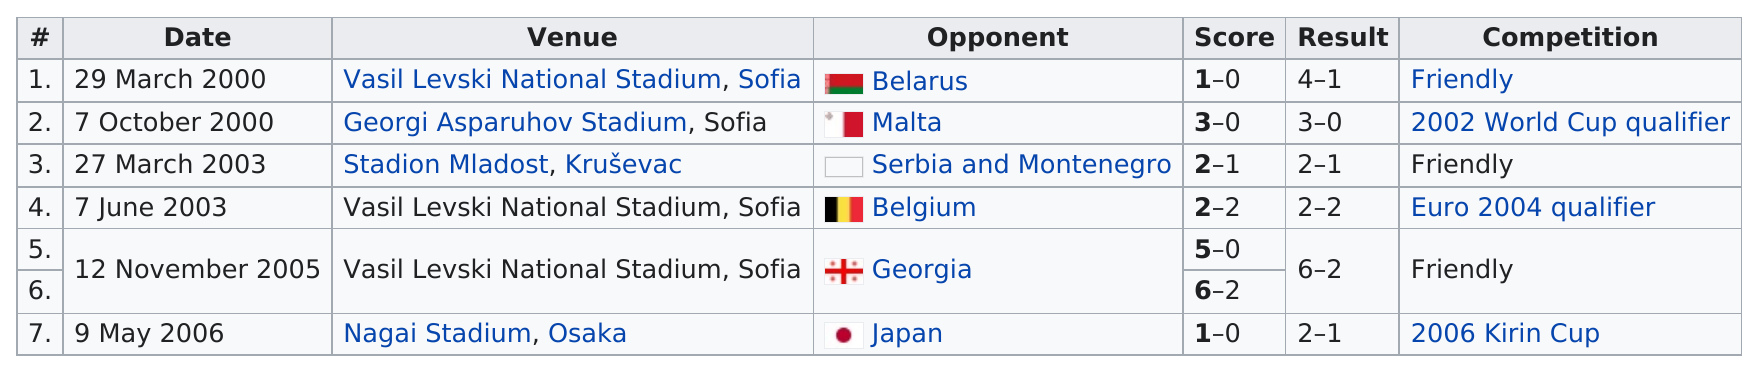Mention a couple of crucial points in this snapshot. In 2003, there were 2 people. After facing Georgia, the opponent was Japan. On May 9th, 2006, the competition was the 2006 Kirin Cup. It is unclear which team, Belgium or Malta, lost by the most points in a game. What opponent is below Belgium? Georgia is! 